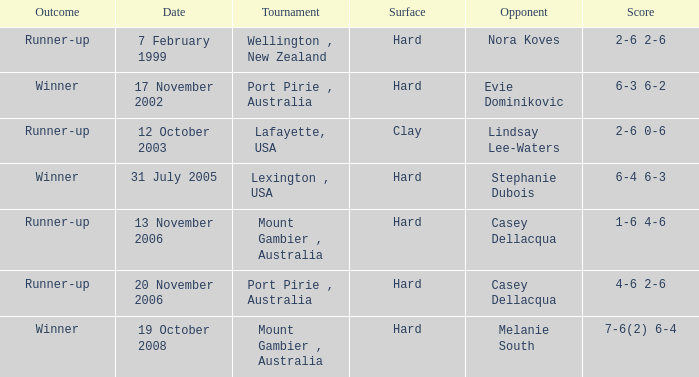Which points have a competitor of melanie south achieved? 7-6(2) 6-4. 